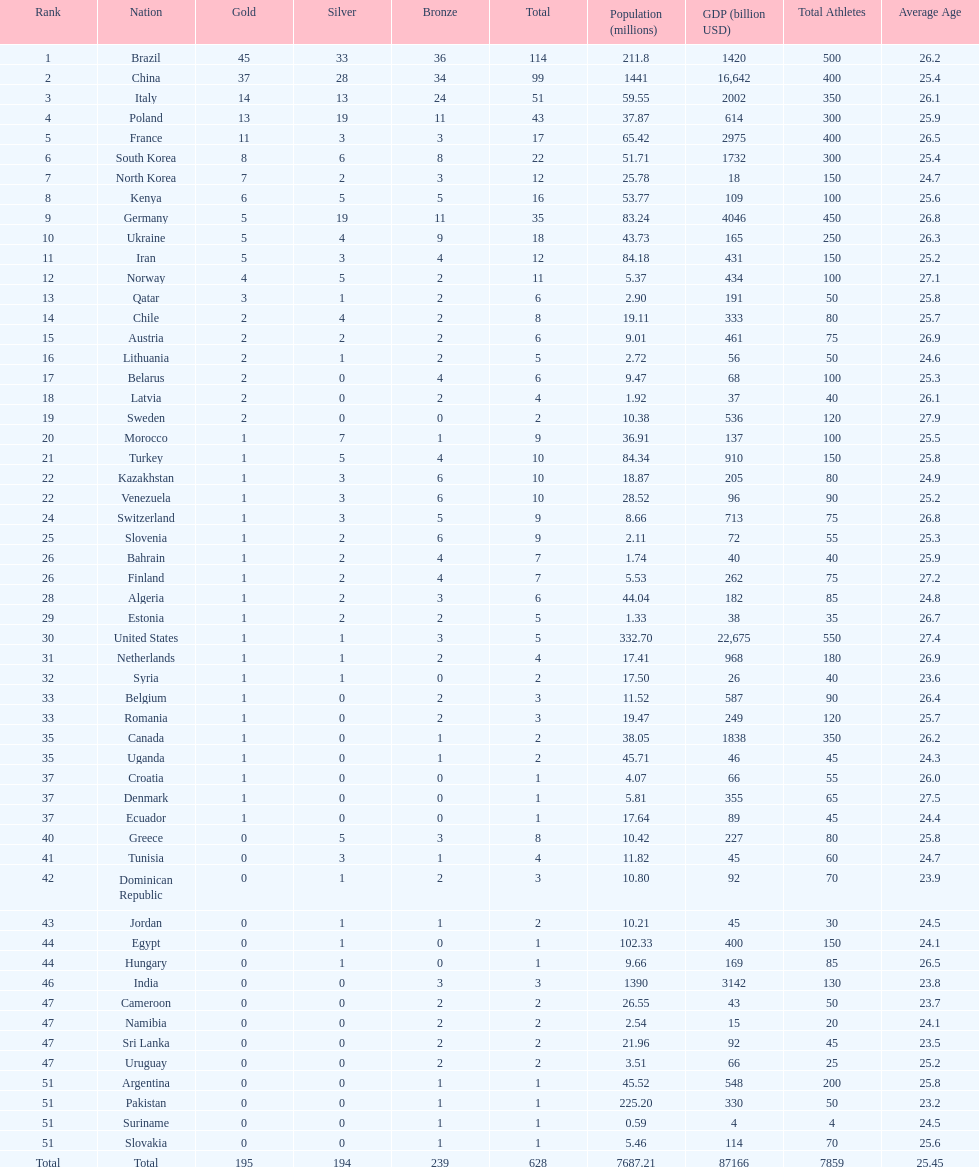Help me parse the entirety of this table. {'header': ['Rank', 'Nation', 'Gold', 'Silver', 'Bronze', 'Total', 'Population (millions)', 'GDP (billion USD)', 'Total Athletes', 'Average Age'], 'rows': [['1', 'Brazil', '45', '33', '36', '114', '211.8', '1420', '500', '26.2'], ['2', 'China', '37', '28', '34', '99', '1441', '16,642', '400', '25.4'], ['3', 'Italy', '14', '13', '24', '51', '59.55', '2002', '350', '26.1'], ['4', 'Poland', '13', '19', '11', '43', '37.87', '614', '300', '25.9'], ['5', 'France', '11', '3', '3', '17', '65.42', '2975', '400', '26.5'], ['6', 'South Korea', '8', '6', '8', '22', '51.71', '1732', '300', '25.4'], ['7', 'North Korea', '7', '2', '3', '12', '25.78', '18', '150', '24.7'], ['8', 'Kenya', '6', '5', '5', '16', '53.77', '109', '100', '25.6'], ['9', 'Germany', '5', '19', '11', '35', '83.24', '4046', '450', '26.8'], ['10', 'Ukraine', '5', '4', '9', '18', '43.73', '165', '250', '26.3'], ['11', 'Iran', '5', '3', '4', '12', '84.18', '431', '150', '25.2'], ['12', 'Norway', '4', '5', '2', '11', '5.37', '434', '100', '27.1'], ['13', 'Qatar', '3', '1', '2', '6', '2.90', '191', '50', '25.8'], ['14', 'Chile', '2', '4', '2', '8', '19.11', '333', '80', '25.7'], ['15', 'Austria', '2', '2', '2', '6', '9.01', '461', '75', '26.9'], ['16', 'Lithuania', '2', '1', '2', '5', '2.72', '56', '50', '24.6'], ['17', 'Belarus', '2', '0', '4', '6', '9.47', '68', '100', '25.3'], ['18', 'Latvia', '2', '0', '2', '4', '1.92', '37', '40', '26.1'], ['19', 'Sweden', '2', '0', '0', '2', '10.38', '536', '120', '27.9'], ['20', 'Morocco', '1', '7', '1', '9', '36.91', '137', '100', '25.5'], ['21', 'Turkey', '1', '5', '4', '10', '84.34', '910', '150', '25.8'], ['22', 'Kazakhstan', '1', '3', '6', '10', '18.87', '205', '80', '24.9'], ['22', 'Venezuela', '1', '3', '6', '10', '28.52', '96', '90', '25.2'], ['24', 'Switzerland', '1', '3', '5', '9', '8.66', '713', '75', '26.8'], ['25', 'Slovenia', '1', '2', '6', '9', '2.11', '72', '55', '25.3'], ['26', 'Bahrain', '1', '2', '4', '7', '1.74', '40', '40', '25.9'], ['26', 'Finland', '1', '2', '4', '7', '5.53', '262', '75', '27.2'], ['28', 'Algeria', '1', '2', '3', '6', '44.04', '182', '85', '24.8'], ['29', 'Estonia', '1', '2', '2', '5', '1.33', '38', '35', '26.7'], ['30', 'United States', '1', '1', '3', '5', '332.70', '22,675', '550', '27.4'], ['31', 'Netherlands', '1', '1', '2', '4', '17.41', '968', '180', '26.9'], ['32', 'Syria', '1', '1', '0', '2', '17.50', '26', '40', '23.6'], ['33', 'Belgium', '1', '0', '2', '3', '11.52', '587', '90', '26.4'], ['33', 'Romania', '1', '0', '2', '3', '19.47', '249', '120', '25.7'], ['35', 'Canada', '1', '0', '1', '2', '38.05', '1838', '350', '26.2'], ['35', 'Uganda', '1', '0', '1', '2', '45.71', '46', '45', '24.3'], ['37', 'Croatia', '1', '0', '0', '1', '4.07', '66', '55', '26.0'], ['37', 'Denmark', '1', '0', '0', '1', '5.81', '355', '65', '27.5'], ['37', 'Ecuador', '1', '0', '0', '1', '17.64', '89', '45', '24.4'], ['40', 'Greece', '0', '5', '3', '8', '10.42', '227', '80', '25.8'], ['41', 'Tunisia', '0', '3', '1', '4', '11.82', '45', '60', '24.7'], ['42', 'Dominican Republic', '0', '1', '2', '3', '10.80', '92', '70', '23.9'], ['43', 'Jordan', '0', '1', '1', '2', '10.21', '45', '30', '24.5'], ['44', 'Egypt', '0', '1', '0', '1', '102.33', '400', '150', '24.1'], ['44', 'Hungary', '0', '1', '0', '1', '9.66', '169', '85', '26.5'], ['46', 'India', '0', '0', '3', '3', '1390', '3142', '130', '23.8'], ['47', 'Cameroon', '0', '0', '2', '2', '26.55', '43', '50', '23.7'], ['47', 'Namibia', '0', '0', '2', '2', '2.54', '15', '20', '24.1'], ['47', 'Sri Lanka', '0', '0', '2', '2', '21.96', '92', '45', '23.5'], ['47', 'Uruguay', '0', '0', '2', '2', '3.51', '66', '25', '25.2'], ['51', 'Argentina', '0', '0', '1', '1', '45.52', '548', '200', '25.8'], ['51', 'Pakistan', '0', '0', '1', '1', '225.20', '330', '50', '23.2'], ['51', 'Suriname', '0', '0', '1', '1', '0.59', '4', '4', '24.5'], ['51', 'Slovakia', '0', '0', '1', '1', '5.46', '114', '70', '25.6'], ['Total', 'Total', '195', '194', '239', '628', '7687.21', '87166', '7859', '25.45']]} Which type of medal does belarus not have? Silver. 